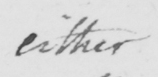Please transcribe the handwritten text in this image. either 